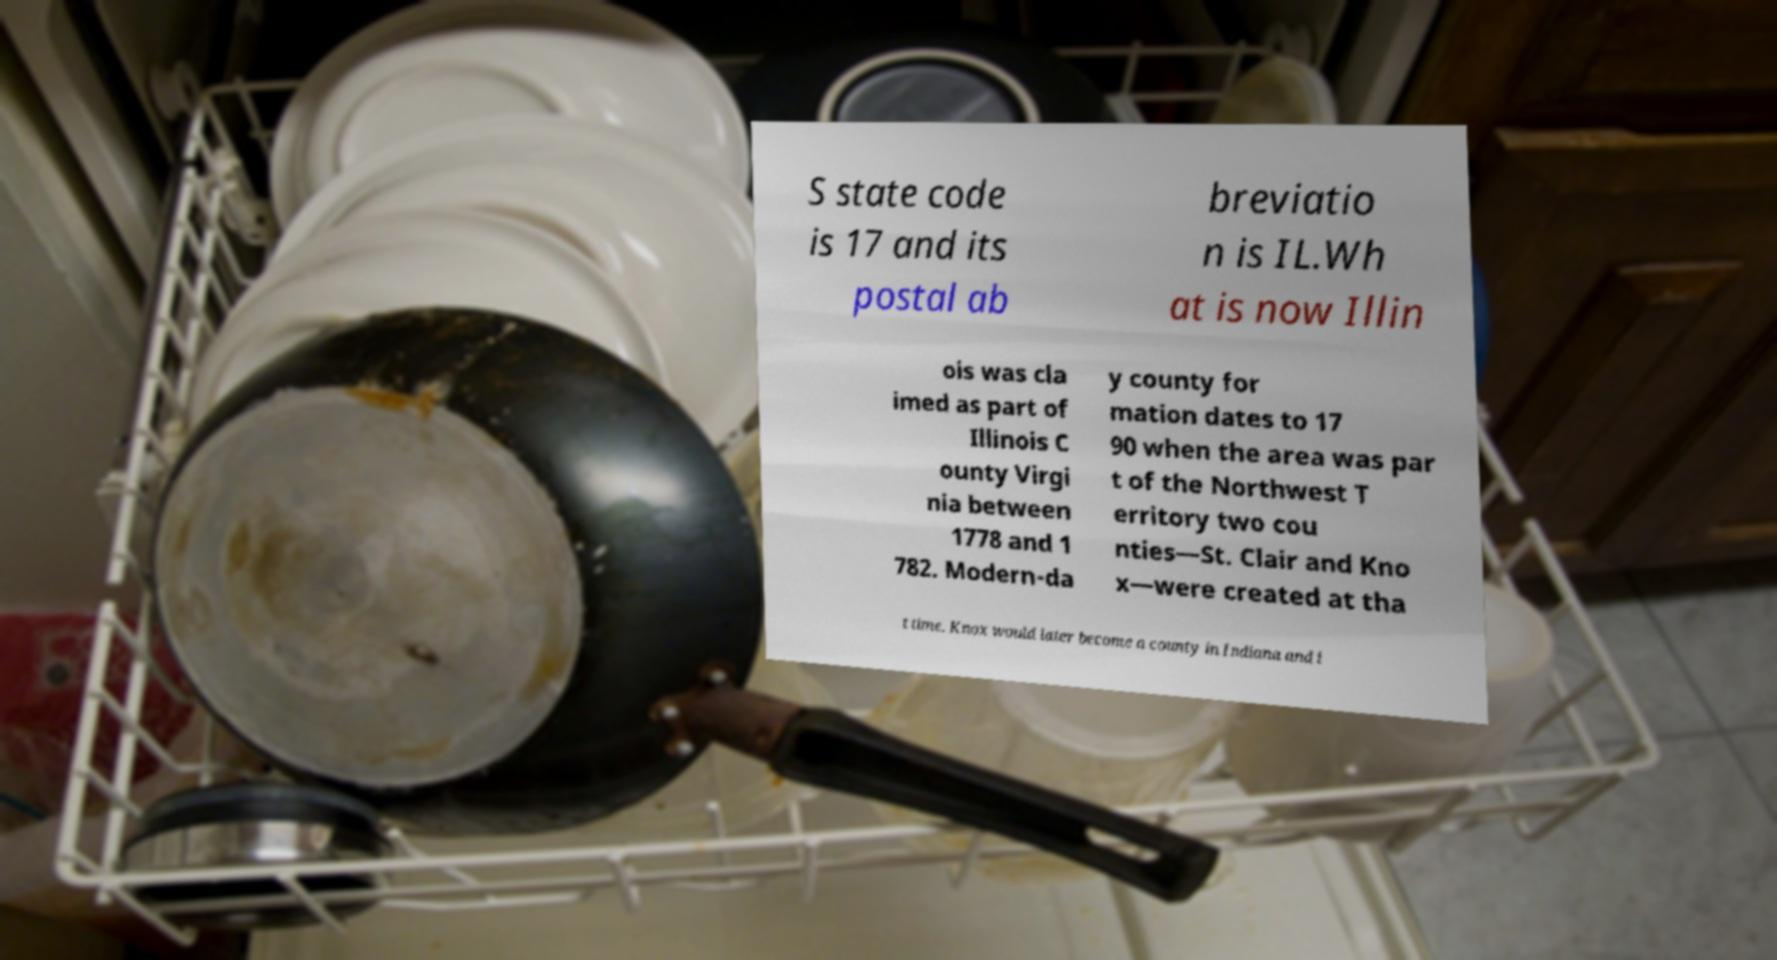Please read and relay the text visible in this image. What does it say? S state code is 17 and its postal ab breviatio n is IL.Wh at is now Illin ois was cla imed as part of Illinois C ounty Virgi nia between 1778 and 1 782. Modern-da y county for mation dates to 17 90 when the area was par t of the Northwest T erritory two cou nties—St. Clair and Kno x—were created at tha t time. Knox would later become a county in Indiana and i 